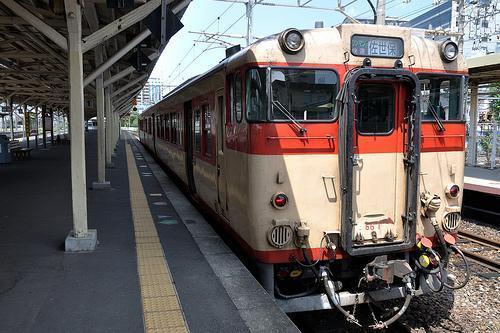How many trains are there?
Give a very brief answer. 1. 